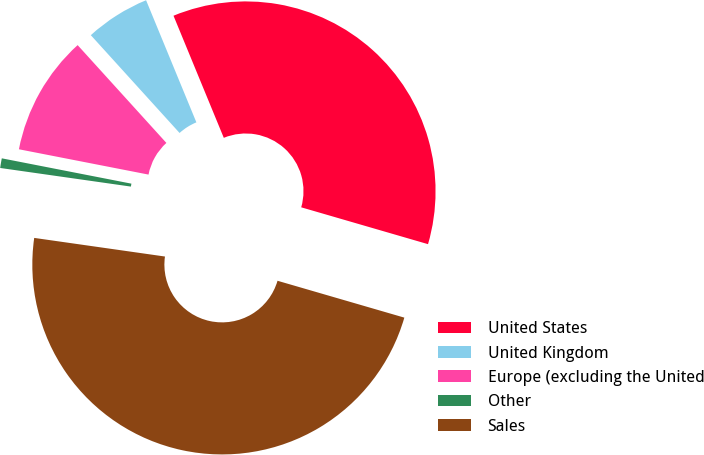Convert chart. <chart><loc_0><loc_0><loc_500><loc_500><pie_chart><fcel>United States<fcel>United Kingdom<fcel>Europe (excluding the United<fcel>Other<fcel>Sales<nl><fcel>35.72%<fcel>5.51%<fcel>10.2%<fcel>0.82%<fcel>47.75%<nl></chart> 